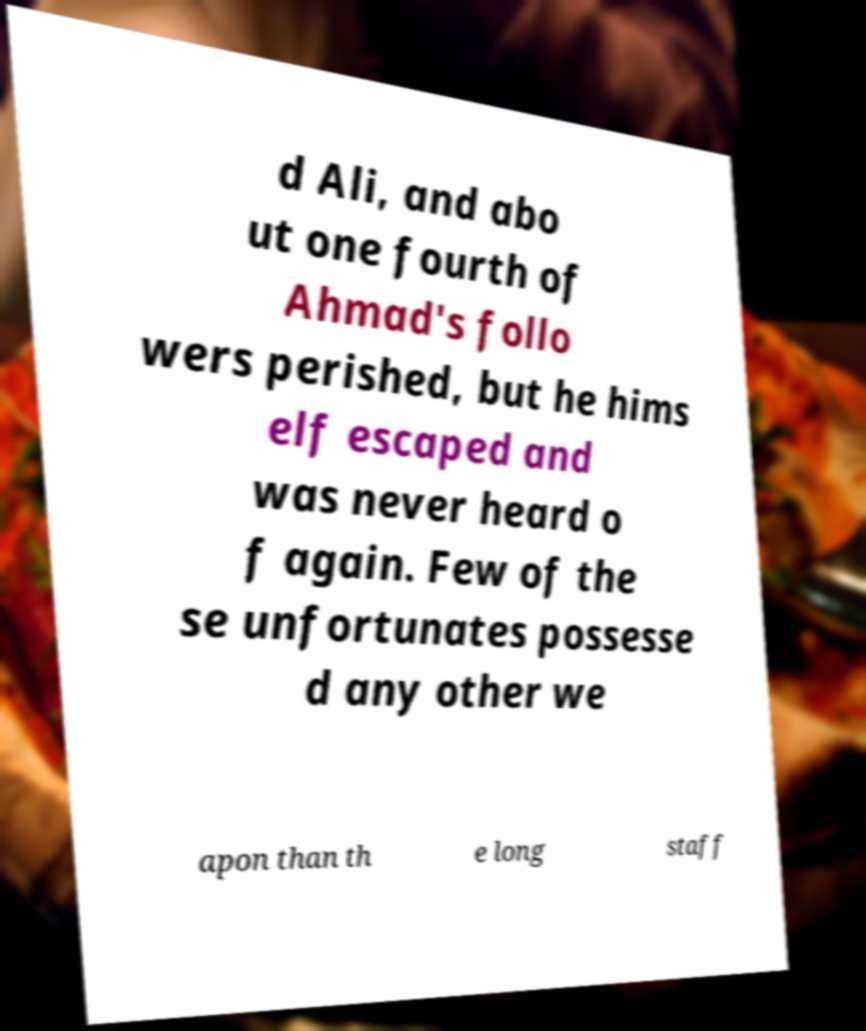Can you accurately transcribe the text from the provided image for me? d Ali, and abo ut one fourth of Ahmad's follo wers perished, but he hims elf escaped and was never heard o f again. Few of the se unfortunates possesse d any other we apon than th e long staff 